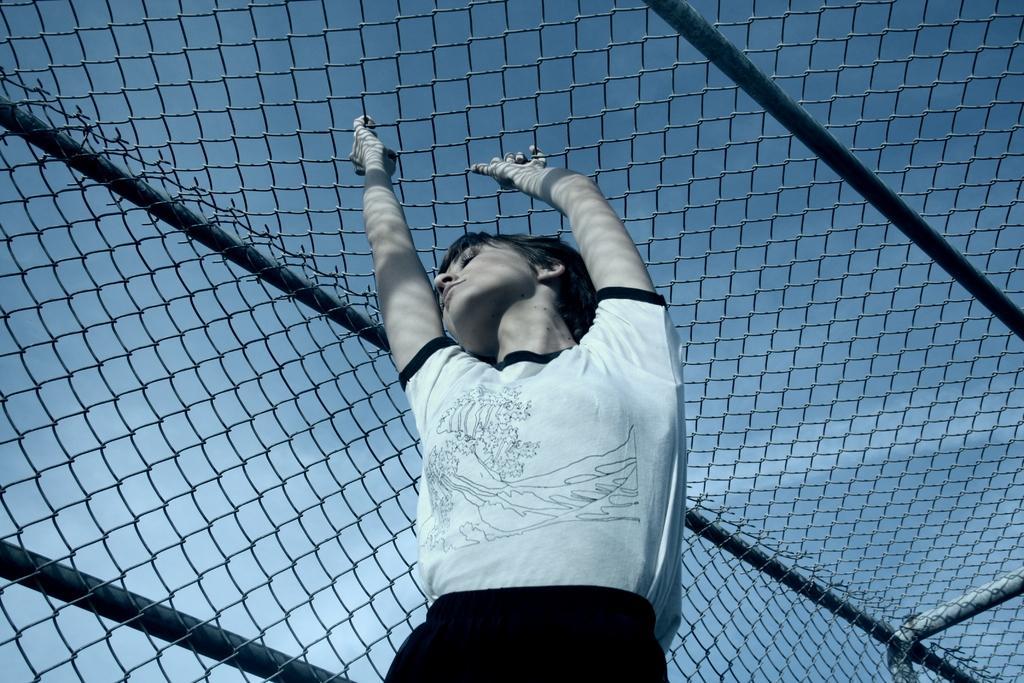In one or two sentences, can you explain what this image depicts? In the image there is a woman standing by holding the mesh above her. 